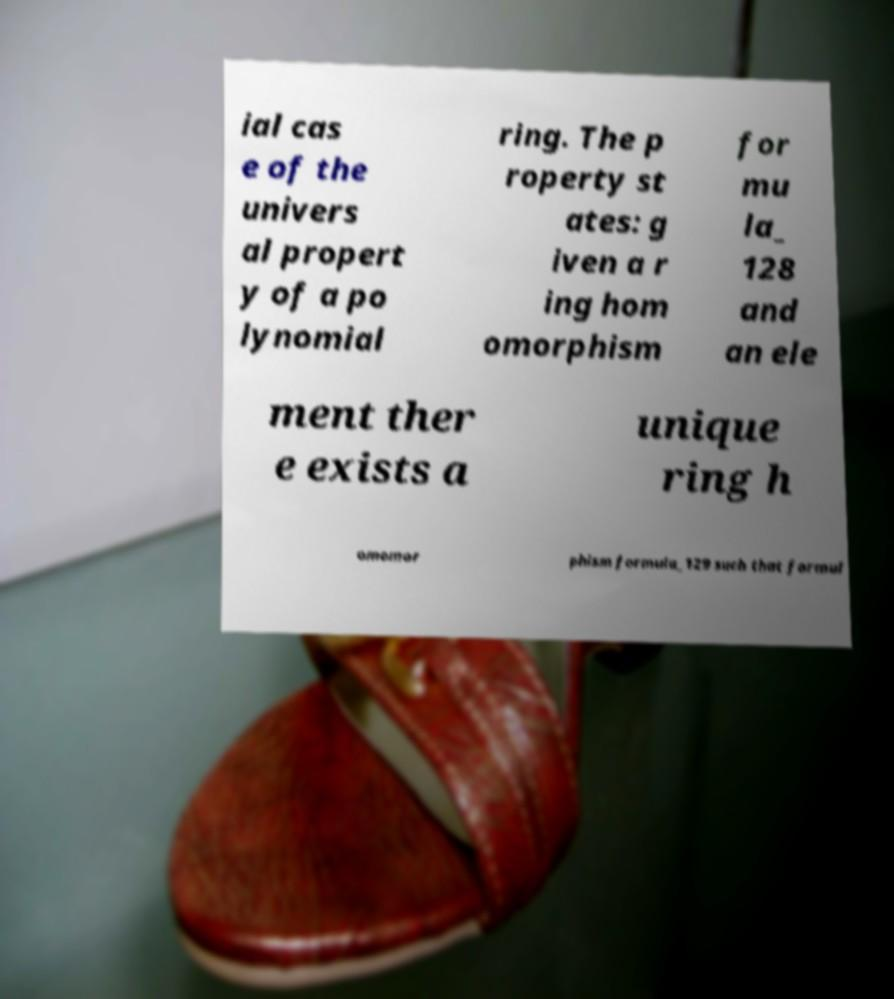Could you extract and type out the text from this image? ial cas e of the univers al propert y of a po lynomial ring. The p roperty st ates: g iven a r ing hom omorphism for mu la_ 128 and an ele ment ther e exists a unique ring h omomor phism formula_129 such that formul 